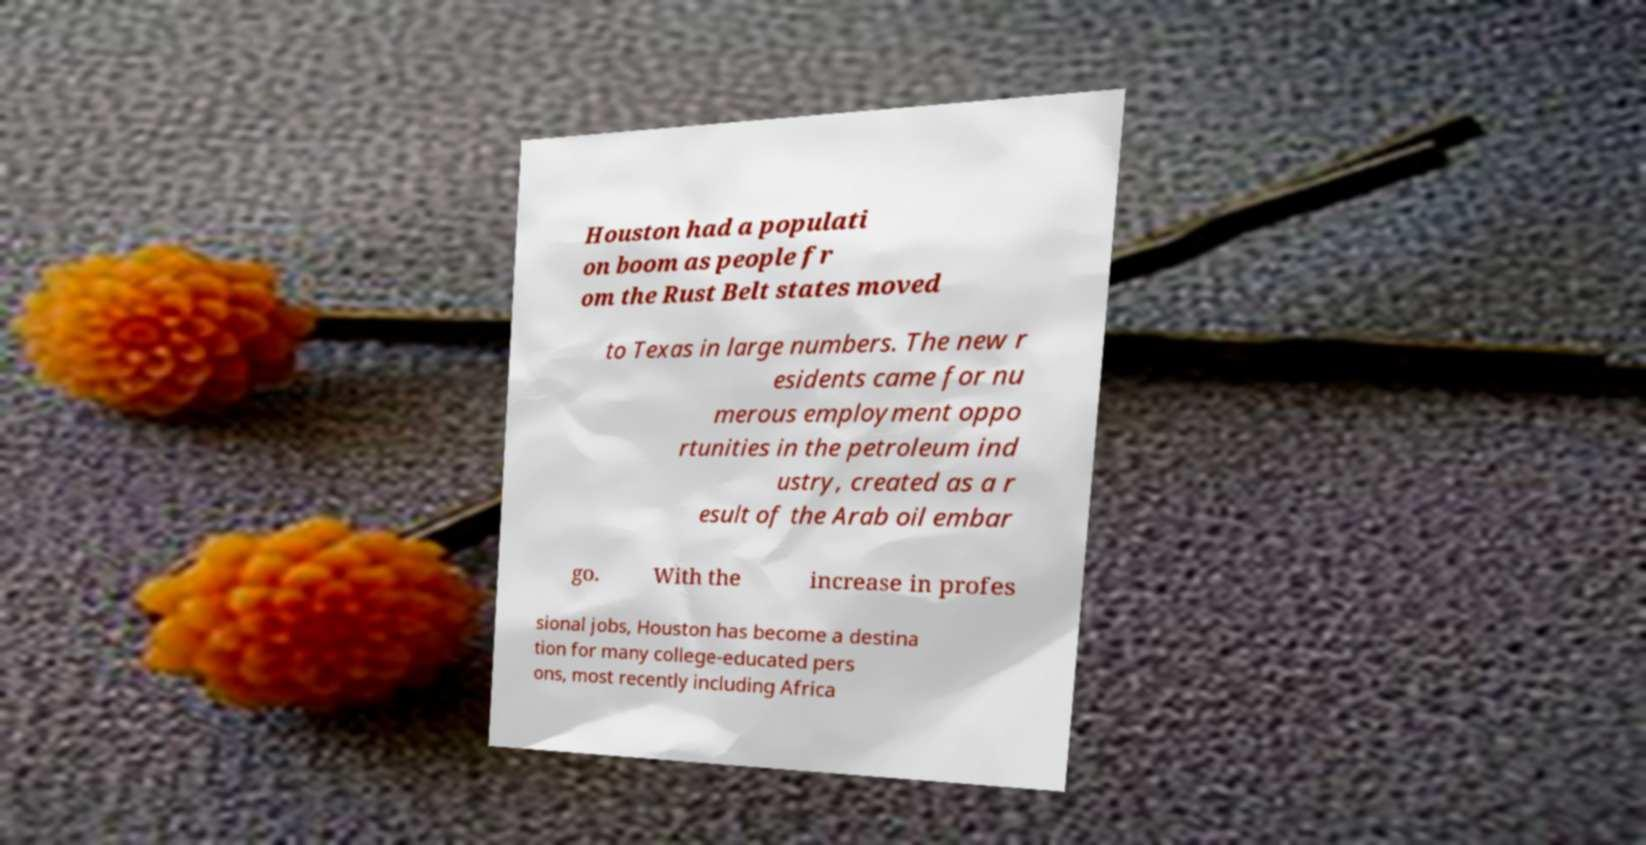Please read and relay the text visible in this image. What does it say? Houston had a populati on boom as people fr om the Rust Belt states moved to Texas in large numbers. The new r esidents came for nu merous employment oppo rtunities in the petroleum ind ustry, created as a r esult of the Arab oil embar go. With the increase in profes sional jobs, Houston has become a destina tion for many college-educated pers ons, most recently including Africa 